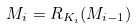<formula> <loc_0><loc_0><loc_500><loc_500>M _ { i } = R _ { K _ { i } } ( M _ { i - 1 } )</formula> 